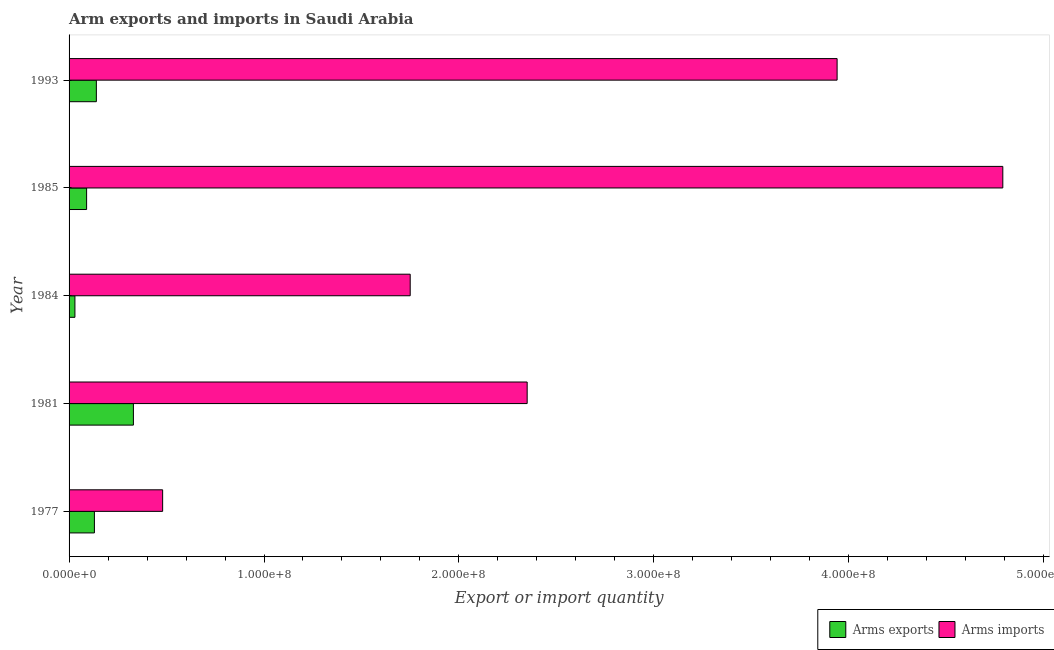How many different coloured bars are there?
Give a very brief answer. 2. How many groups of bars are there?
Offer a very short reply. 5. How many bars are there on the 2nd tick from the bottom?
Your answer should be compact. 2. What is the label of the 4th group of bars from the top?
Give a very brief answer. 1981. In how many cases, is the number of bars for a given year not equal to the number of legend labels?
Provide a short and direct response. 0. What is the arms exports in 1993?
Provide a succinct answer. 1.40e+07. Across all years, what is the maximum arms exports?
Offer a very short reply. 3.30e+07. Across all years, what is the minimum arms imports?
Provide a short and direct response. 4.80e+07. In which year was the arms exports minimum?
Make the answer very short. 1984. What is the total arms exports in the graph?
Give a very brief answer. 7.20e+07. What is the difference between the arms imports in 1984 and that in 1985?
Ensure brevity in your answer.  -3.04e+08. What is the difference between the arms exports in 1981 and the arms imports in 1993?
Make the answer very short. -3.61e+08. What is the average arms exports per year?
Offer a terse response. 1.44e+07. In the year 1977, what is the difference between the arms imports and arms exports?
Give a very brief answer. 3.50e+07. In how many years, is the arms imports greater than 240000000 ?
Offer a very short reply. 2. What is the ratio of the arms imports in 1981 to that in 1984?
Ensure brevity in your answer.  1.34. Is the arms imports in 1984 less than that in 1985?
Provide a short and direct response. Yes. Is the difference between the arms exports in 1977 and 1985 greater than the difference between the arms imports in 1977 and 1985?
Provide a short and direct response. Yes. What is the difference between the highest and the second highest arms imports?
Your answer should be compact. 8.50e+07. What is the difference between the highest and the lowest arms exports?
Keep it short and to the point. 3.00e+07. What does the 2nd bar from the top in 1993 represents?
Offer a terse response. Arms exports. What does the 1st bar from the bottom in 1993 represents?
Ensure brevity in your answer.  Arms exports. How many bars are there?
Give a very brief answer. 10. Are all the bars in the graph horizontal?
Make the answer very short. Yes. What is the difference between two consecutive major ticks on the X-axis?
Your response must be concise. 1.00e+08. Are the values on the major ticks of X-axis written in scientific E-notation?
Offer a very short reply. Yes. Does the graph contain any zero values?
Offer a very short reply. No. Where does the legend appear in the graph?
Offer a very short reply. Bottom right. What is the title of the graph?
Your answer should be very brief. Arm exports and imports in Saudi Arabia. What is the label or title of the X-axis?
Your answer should be very brief. Export or import quantity. What is the label or title of the Y-axis?
Provide a succinct answer. Year. What is the Export or import quantity of Arms exports in 1977?
Give a very brief answer. 1.30e+07. What is the Export or import quantity of Arms imports in 1977?
Make the answer very short. 4.80e+07. What is the Export or import quantity of Arms exports in 1981?
Ensure brevity in your answer.  3.30e+07. What is the Export or import quantity of Arms imports in 1981?
Give a very brief answer. 2.35e+08. What is the Export or import quantity in Arms exports in 1984?
Your response must be concise. 3.00e+06. What is the Export or import quantity of Arms imports in 1984?
Your answer should be compact. 1.75e+08. What is the Export or import quantity of Arms exports in 1985?
Your answer should be very brief. 9.00e+06. What is the Export or import quantity of Arms imports in 1985?
Provide a succinct answer. 4.79e+08. What is the Export or import quantity in Arms exports in 1993?
Provide a short and direct response. 1.40e+07. What is the Export or import quantity in Arms imports in 1993?
Your response must be concise. 3.94e+08. Across all years, what is the maximum Export or import quantity of Arms exports?
Give a very brief answer. 3.30e+07. Across all years, what is the maximum Export or import quantity of Arms imports?
Ensure brevity in your answer.  4.79e+08. Across all years, what is the minimum Export or import quantity in Arms exports?
Your response must be concise. 3.00e+06. Across all years, what is the minimum Export or import quantity in Arms imports?
Ensure brevity in your answer.  4.80e+07. What is the total Export or import quantity of Arms exports in the graph?
Give a very brief answer. 7.20e+07. What is the total Export or import quantity of Arms imports in the graph?
Your answer should be compact. 1.33e+09. What is the difference between the Export or import quantity of Arms exports in 1977 and that in 1981?
Your response must be concise. -2.00e+07. What is the difference between the Export or import quantity of Arms imports in 1977 and that in 1981?
Ensure brevity in your answer.  -1.87e+08. What is the difference between the Export or import quantity in Arms exports in 1977 and that in 1984?
Offer a very short reply. 1.00e+07. What is the difference between the Export or import quantity of Arms imports in 1977 and that in 1984?
Provide a short and direct response. -1.27e+08. What is the difference between the Export or import quantity of Arms exports in 1977 and that in 1985?
Offer a terse response. 4.00e+06. What is the difference between the Export or import quantity in Arms imports in 1977 and that in 1985?
Make the answer very short. -4.31e+08. What is the difference between the Export or import quantity of Arms exports in 1977 and that in 1993?
Offer a terse response. -1.00e+06. What is the difference between the Export or import quantity in Arms imports in 1977 and that in 1993?
Make the answer very short. -3.46e+08. What is the difference between the Export or import quantity in Arms exports in 1981 and that in 1984?
Your answer should be compact. 3.00e+07. What is the difference between the Export or import quantity in Arms imports in 1981 and that in 1984?
Ensure brevity in your answer.  6.00e+07. What is the difference between the Export or import quantity of Arms exports in 1981 and that in 1985?
Your response must be concise. 2.40e+07. What is the difference between the Export or import quantity in Arms imports in 1981 and that in 1985?
Make the answer very short. -2.44e+08. What is the difference between the Export or import quantity of Arms exports in 1981 and that in 1993?
Offer a terse response. 1.90e+07. What is the difference between the Export or import quantity in Arms imports in 1981 and that in 1993?
Your answer should be very brief. -1.59e+08. What is the difference between the Export or import quantity of Arms exports in 1984 and that in 1985?
Ensure brevity in your answer.  -6.00e+06. What is the difference between the Export or import quantity of Arms imports in 1984 and that in 1985?
Offer a very short reply. -3.04e+08. What is the difference between the Export or import quantity in Arms exports in 1984 and that in 1993?
Provide a succinct answer. -1.10e+07. What is the difference between the Export or import quantity of Arms imports in 1984 and that in 1993?
Keep it short and to the point. -2.19e+08. What is the difference between the Export or import quantity of Arms exports in 1985 and that in 1993?
Your response must be concise. -5.00e+06. What is the difference between the Export or import quantity in Arms imports in 1985 and that in 1993?
Ensure brevity in your answer.  8.50e+07. What is the difference between the Export or import quantity of Arms exports in 1977 and the Export or import quantity of Arms imports in 1981?
Provide a succinct answer. -2.22e+08. What is the difference between the Export or import quantity in Arms exports in 1977 and the Export or import quantity in Arms imports in 1984?
Offer a terse response. -1.62e+08. What is the difference between the Export or import quantity in Arms exports in 1977 and the Export or import quantity in Arms imports in 1985?
Ensure brevity in your answer.  -4.66e+08. What is the difference between the Export or import quantity of Arms exports in 1977 and the Export or import quantity of Arms imports in 1993?
Give a very brief answer. -3.81e+08. What is the difference between the Export or import quantity in Arms exports in 1981 and the Export or import quantity in Arms imports in 1984?
Provide a succinct answer. -1.42e+08. What is the difference between the Export or import quantity of Arms exports in 1981 and the Export or import quantity of Arms imports in 1985?
Your answer should be compact. -4.46e+08. What is the difference between the Export or import quantity in Arms exports in 1981 and the Export or import quantity in Arms imports in 1993?
Ensure brevity in your answer.  -3.61e+08. What is the difference between the Export or import quantity of Arms exports in 1984 and the Export or import quantity of Arms imports in 1985?
Give a very brief answer. -4.76e+08. What is the difference between the Export or import quantity in Arms exports in 1984 and the Export or import quantity in Arms imports in 1993?
Offer a very short reply. -3.91e+08. What is the difference between the Export or import quantity of Arms exports in 1985 and the Export or import quantity of Arms imports in 1993?
Give a very brief answer. -3.85e+08. What is the average Export or import quantity of Arms exports per year?
Provide a short and direct response. 1.44e+07. What is the average Export or import quantity in Arms imports per year?
Offer a terse response. 2.66e+08. In the year 1977, what is the difference between the Export or import quantity of Arms exports and Export or import quantity of Arms imports?
Keep it short and to the point. -3.50e+07. In the year 1981, what is the difference between the Export or import quantity in Arms exports and Export or import quantity in Arms imports?
Give a very brief answer. -2.02e+08. In the year 1984, what is the difference between the Export or import quantity in Arms exports and Export or import quantity in Arms imports?
Make the answer very short. -1.72e+08. In the year 1985, what is the difference between the Export or import quantity in Arms exports and Export or import quantity in Arms imports?
Give a very brief answer. -4.70e+08. In the year 1993, what is the difference between the Export or import quantity in Arms exports and Export or import quantity in Arms imports?
Offer a terse response. -3.80e+08. What is the ratio of the Export or import quantity of Arms exports in 1977 to that in 1981?
Your answer should be very brief. 0.39. What is the ratio of the Export or import quantity in Arms imports in 1977 to that in 1981?
Provide a short and direct response. 0.2. What is the ratio of the Export or import quantity in Arms exports in 1977 to that in 1984?
Provide a short and direct response. 4.33. What is the ratio of the Export or import quantity of Arms imports in 1977 to that in 1984?
Your response must be concise. 0.27. What is the ratio of the Export or import quantity of Arms exports in 1977 to that in 1985?
Ensure brevity in your answer.  1.44. What is the ratio of the Export or import quantity of Arms imports in 1977 to that in 1985?
Your answer should be compact. 0.1. What is the ratio of the Export or import quantity in Arms exports in 1977 to that in 1993?
Offer a terse response. 0.93. What is the ratio of the Export or import quantity of Arms imports in 1977 to that in 1993?
Your response must be concise. 0.12. What is the ratio of the Export or import quantity in Arms imports in 1981 to that in 1984?
Your answer should be compact. 1.34. What is the ratio of the Export or import quantity in Arms exports in 1981 to that in 1985?
Your answer should be compact. 3.67. What is the ratio of the Export or import quantity of Arms imports in 1981 to that in 1985?
Provide a succinct answer. 0.49. What is the ratio of the Export or import quantity in Arms exports in 1981 to that in 1993?
Your answer should be very brief. 2.36. What is the ratio of the Export or import quantity of Arms imports in 1981 to that in 1993?
Your answer should be very brief. 0.6. What is the ratio of the Export or import quantity of Arms imports in 1984 to that in 1985?
Offer a terse response. 0.37. What is the ratio of the Export or import quantity of Arms exports in 1984 to that in 1993?
Keep it short and to the point. 0.21. What is the ratio of the Export or import quantity of Arms imports in 1984 to that in 1993?
Your answer should be compact. 0.44. What is the ratio of the Export or import quantity of Arms exports in 1985 to that in 1993?
Provide a short and direct response. 0.64. What is the ratio of the Export or import quantity of Arms imports in 1985 to that in 1993?
Offer a terse response. 1.22. What is the difference between the highest and the second highest Export or import quantity in Arms exports?
Ensure brevity in your answer.  1.90e+07. What is the difference between the highest and the second highest Export or import quantity of Arms imports?
Offer a very short reply. 8.50e+07. What is the difference between the highest and the lowest Export or import quantity in Arms exports?
Your response must be concise. 3.00e+07. What is the difference between the highest and the lowest Export or import quantity of Arms imports?
Offer a very short reply. 4.31e+08. 